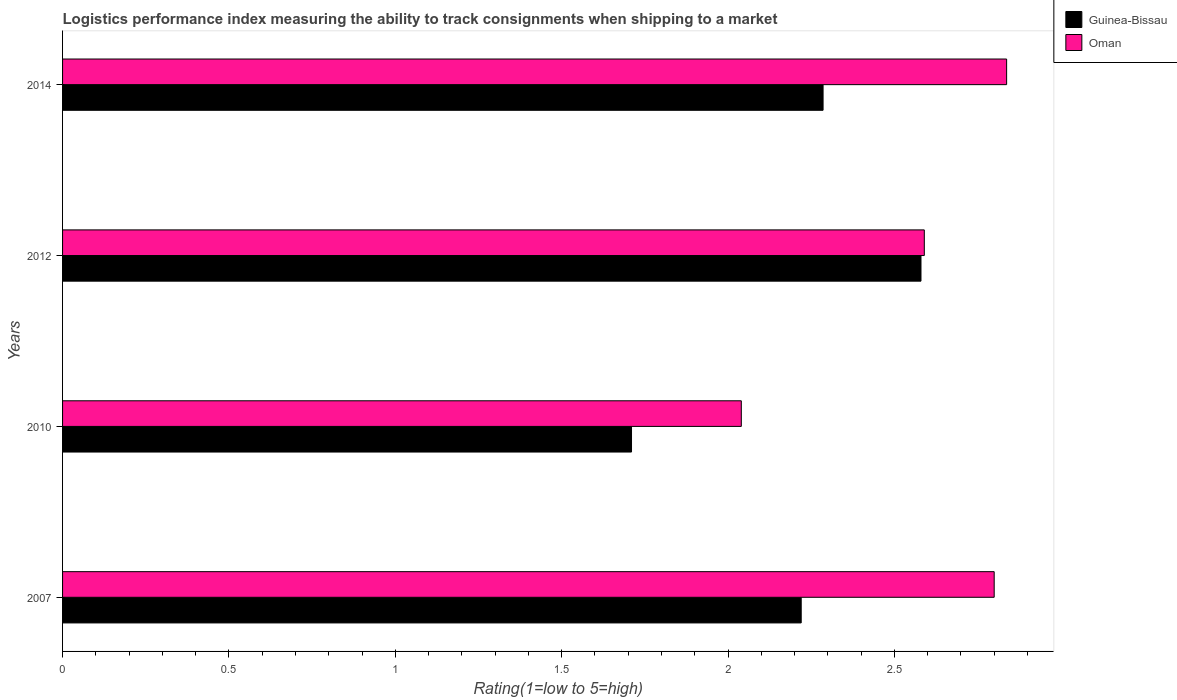How many groups of bars are there?
Provide a short and direct response. 4. Are the number of bars on each tick of the Y-axis equal?
Offer a very short reply. Yes. How many bars are there on the 2nd tick from the bottom?
Keep it short and to the point. 2. What is the label of the 4th group of bars from the top?
Offer a terse response. 2007. In how many cases, is the number of bars for a given year not equal to the number of legend labels?
Your answer should be compact. 0. What is the Logistic performance index in Oman in 2010?
Offer a very short reply. 2.04. Across all years, what is the maximum Logistic performance index in Oman?
Offer a very short reply. 2.84. Across all years, what is the minimum Logistic performance index in Oman?
Provide a short and direct response. 2.04. What is the total Logistic performance index in Oman in the graph?
Offer a very short reply. 10.27. What is the difference between the Logistic performance index in Guinea-Bissau in 2007 and that in 2012?
Give a very brief answer. -0.36. What is the difference between the Logistic performance index in Oman in 2010 and the Logistic performance index in Guinea-Bissau in 2014?
Your response must be concise. -0.25. What is the average Logistic performance index in Guinea-Bissau per year?
Offer a very short reply. 2.2. In the year 2012, what is the difference between the Logistic performance index in Oman and Logistic performance index in Guinea-Bissau?
Give a very brief answer. 0.01. What is the ratio of the Logistic performance index in Oman in 2010 to that in 2012?
Offer a very short reply. 0.79. Is the difference between the Logistic performance index in Oman in 2010 and 2012 greater than the difference between the Logistic performance index in Guinea-Bissau in 2010 and 2012?
Make the answer very short. Yes. What is the difference between the highest and the second highest Logistic performance index in Guinea-Bissau?
Provide a short and direct response. 0.29. What is the difference between the highest and the lowest Logistic performance index in Oman?
Keep it short and to the point. 0.8. What does the 1st bar from the top in 2010 represents?
Make the answer very short. Oman. What does the 1st bar from the bottom in 2007 represents?
Your response must be concise. Guinea-Bissau. Are all the bars in the graph horizontal?
Keep it short and to the point. Yes. How many years are there in the graph?
Keep it short and to the point. 4. What is the difference between two consecutive major ticks on the X-axis?
Keep it short and to the point. 0.5. What is the title of the graph?
Give a very brief answer. Logistics performance index measuring the ability to track consignments when shipping to a market. Does "Tanzania" appear as one of the legend labels in the graph?
Offer a terse response. No. What is the label or title of the X-axis?
Your answer should be very brief. Rating(1=low to 5=high). What is the Rating(1=low to 5=high) in Guinea-Bissau in 2007?
Give a very brief answer. 2.22. What is the Rating(1=low to 5=high) of Oman in 2007?
Ensure brevity in your answer.  2.8. What is the Rating(1=low to 5=high) of Guinea-Bissau in 2010?
Offer a terse response. 1.71. What is the Rating(1=low to 5=high) in Oman in 2010?
Offer a very short reply. 2.04. What is the Rating(1=low to 5=high) of Guinea-Bissau in 2012?
Provide a succinct answer. 2.58. What is the Rating(1=low to 5=high) of Oman in 2012?
Offer a terse response. 2.59. What is the Rating(1=low to 5=high) of Guinea-Bissau in 2014?
Offer a terse response. 2.29. What is the Rating(1=low to 5=high) in Oman in 2014?
Make the answer very short. 2.84. Across all years, what is the maximum Rating(1=low to 5=high) in Guinea-Bissau?
Offer a terse response. 2.58. Across all years, what is the maximum Rating(1=low to 5=high) of Oman?
Ensure brevity in your answer.  2.84. Across all years, what is the minimum Rating(1=low to 5=high) in Guinea-Bissau?
Ensure brevity in your answer.  1.71. Across all years, what is the minimum Rating(1=low to 5=high) of Oman?
Your answer should be compact. 2.04. What is the total Rating(1=low to 5=high) in Guinea-Bissau in the graph?
Provide a short and direct response. 8.8. What is the total Rating(1=low to 5=high) of Oman in the graph?
Make the answer very short. 10.27. What is the difference between the Rating(1=low to 5=high) in Guinea-Bissau in 2007 and that in 2010?
Provide a short and direct response. 0.51. What is the difference between the Rating(1=low to 5=high) in Oman in 2007 and that in 2010?
Offer a very short reply. 0.76. What is the difference between the Rating(1=low to 5=high) in Guinea-Bissau in 2007 and that in 2012?
Your answer should be compact. -0.36. What is the difference between the Rating(1=low to 5=high) in Oman in 2007 and that in 2012?
Ensure brevity in your answer.  0.21. What is the difference between the Rating(1=low to 5=high) of Guinea-Bissau in 2007 and that in 2014?
Your answer should be compact. -0.07. What is the difference between the Rating(1=low to 5=high) of Oman in 2007 and that in 2014?
Your response must be concise. -0.04. What is the difference between the Rating(1=low to 5=high) of Guinea-Bissau in 2010 and that in 2012?
Your answer should be very brief. -0.87. What is the difference between the Rating(1=low to 5=high) in Oman in 2010 and that in 2012?
Provide a short and direct response. -0.55. What is the difference between the Rating(1=low to 5=high) in Guinea-Bissau in 2010 and that in 2014?
Offer a terse response. -0.58. What is the difference between the Rating(1=low to 5=high) of Oman in 2010 and that in 2014?
Offer a very short reply. -0.8. What is the difference between the Rating(1=low to 5=high) of Guinea-Bissau in 2012 and that in 2014?
Keep it short and to the point. 0.29. What is the difference between the Rating(1=low to 5=high) in Oman in 2012 and that in 2014?
Your answer should be very brief. -0.25. What is the difference between the Rating(1=low to 5=high) in Guinea-Bissau in 2007 and the Rating(1=low to 5=high) in Oman in 2010?
Ensure brevity in your answer.  0.18. What is the difference between the Rating(1=low to 5=high) in Guinea-Bissau in 2007 and the Rating(1=low to 5=high) in Oman in 2012?
Your answer should be compact. -0.37. What is the difference between the Rating(1=low to 5=high) in Guinea-Bissau in 2007 and the Rating(1=low to 5=high) in Oman in 2014?
Make the answer very short. -0.62. What is the difference between the Rating(1=low to 5=high) of Guinea-Bissau in 2010 and the Rating(1=low to 5=high) of Oman in 2012?
Provide a short and direct response. -0.88. What is the difference between the Rating(1=low to 5=high) of Guinea-Bissau in 2010 and the Rating(1=low to 5=high) of Oman in 2014?
Offer a terse response. -1.13. What is the difference between the Rating(1=low to 5=high) in Guinea-Bissau in 2012 and the Rating(1=low to 5=high) in Oman in 2014?
Offer a terse response. -0.26. What is the average Rating(1=low to 5=high) in Guinea-Bissau per year?
Give a very brief answer. 2.2. What is the average Rating(1=low to 5=high) in Oman per year?
Provide a succinct answer. 2.57. In the year 2007, what is the difference between the Rating(1=low to 5=high) of Guinea-Bissau and Rating(1=low to 5=high) of Oman?
Offer a very short reply. -0.58. In the year 2010, what is the difference between the Rating(1=low to 5=high) of Guinea-Bissau and Rating(1=low to 5=high) of Oman?
Ensure brevity in your answer.  -0.33. In the year 2012, what is the difference between the Rating(1=low to 5=high) in Guinea-Bissau and Rating(1=low to 5=high) in Oman?
Provide a short and direct response. -0.01. In the year 2014, what is the difference between the Rating(1=low to 5=high) in Guinea-Bissau and Rating(1=low to 5=high) in Oman?
Make the answer very short. -0.55. What is the ratio of the Rating(1=low to 5=high) of Guinea-Bissau in 2007 to that in 2010?
Offer a very short reply. 1.3. What is the ratio of the Rating(1=low to 5=high) of Oman in 2007 to that in 2010?
Keep it short and to the point. 1.37. What is the ratio of the Rating(1=low to 5=high) in Guinea-Bissau in 2007 to that in 2012?
Your answer should be compact. 0.86. What is the ratio of the Rating(1=low to 5=high) of Oman in 2007 to that in 2012?
Your response must be concise. 1.08. What is the ratio of the Rating(1=low to 5=high) of Guinea-Bissau in 2007 to that in 2014?
Your answer should be very brief. 0.97. What is the ratio of the Rating(1=low to 5=high) in Oman in 2007 to that in 2014?
Offer a very short reply. 0.99. What is the ratio of the Rating(1=low to 5=high) of Guinea-Bissau in 2010 to that in 2012?
Provide a short and direct response. 0.66. What is the ratio of the Rating(1=low to 5=high) of Oman in 2010 to that in 2012?
Give a very brief answer. 0.79. What is the ratio of the Rating(1=low to 5=high) of Guinea-Bissau in 2010 to that in 2014?
Make the answer very short. 0.75. What is the ratio of the Rating(1=low to 5=high) of Oman in 2010 to that in 2014?
Your response must be concise. 0.72. What is the ratio of the Rating(1=low to 5=high) of Guinea-Bissau in 2012 to that in 2014?
Keep it short and to the point. 1.13. What is the ratio of the Rating(1=low to 5=high) in Oman in 2012 to that in 2014?
Ensure brevity in your answer.  0.91. What is the difference between the highest and the second highest Rating(1=low to 5=high) in Guinea-Bissau?
Your response must be concise. 0.29. What is the difference between the highest and the second highest Rating(1=low to 5=high) of Oman?
Your answer should be very brief. 0.04. What is the difference between the highest and the lowest Rating(1=low to 5=high) of Guinea-Bissau?
Provide a succinct answer. 0.87. What is the difference between the highest and the lowest Rating(1=low to 5=high) in Oman?
Your answer should be compact. 0.8. 